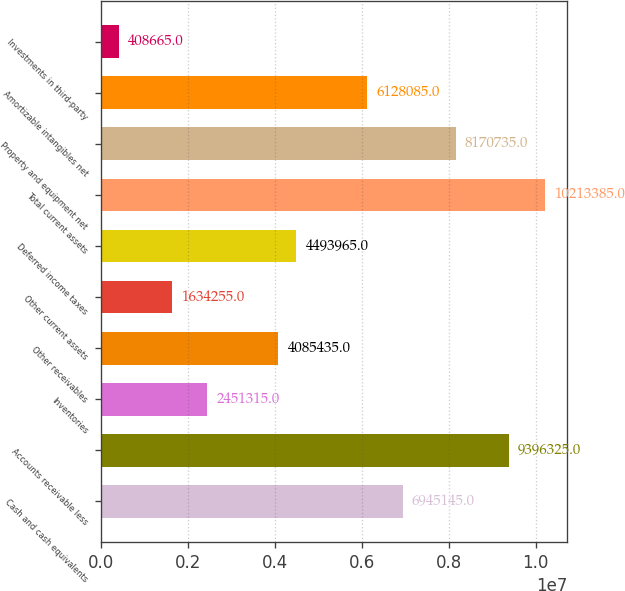Convert chart. <chart><loc_0><loc_0><loc_500><loc_500><bar_chart><fcel>Cash and cash equivalents<fcel>Accounts receivable less<fcel>Inventories<fcel>Other receivables<fcel>Other current assets<fcel>Deferred income taxes<fcel>Total current assets<fcel>Property and equipment net<fcel>Amortizable intangibles net<fcel>Investments in third-party<nl><fcel>6.94514e+06<fcel>9.39632e+06<fcel>2.45132e+06<fcel>4.08544e+06<fcel>1.63426e+06<fcel>4.49396e+06<fcel>1.02134e+07<fcel>8.17074e+06<fcel>6.12808e+06<fcel>408665<nl></chart> 